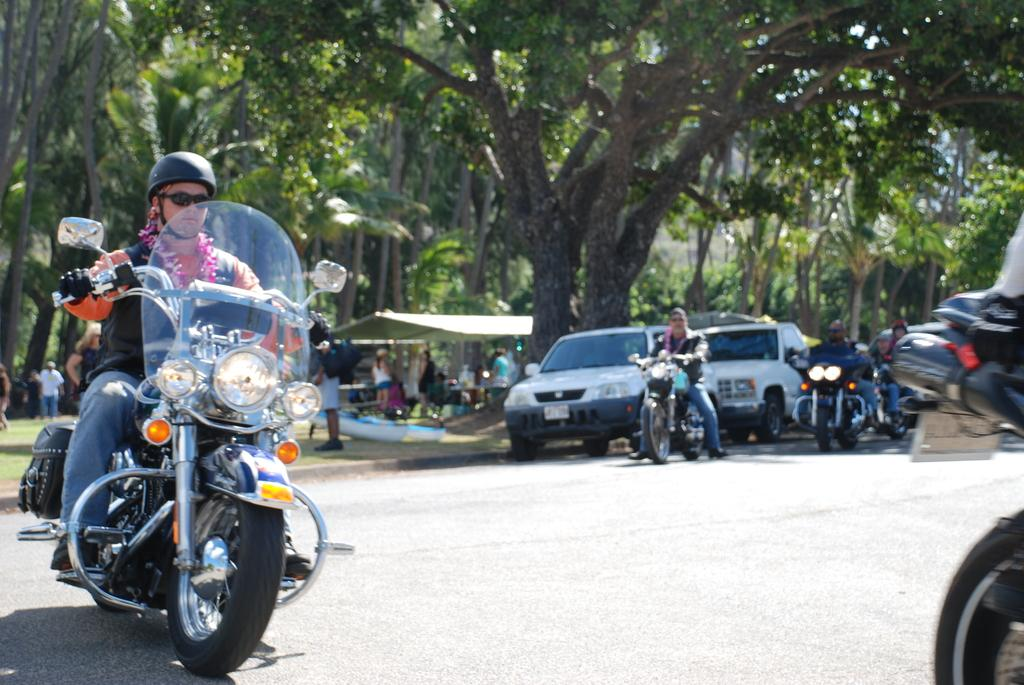What type of scene is depicted in the image? The image appears to be a roadside view. What vehicles can be seen on the road? There are bikes and cars on the road. What type of vegetation is present in the area surrounding the road? There are trees in the area surrounding the road. What type of music can be heard playing from the actor's car in the image? There is no actor or car audio system playing music in the image; it only shows bikes and cars on the road. 